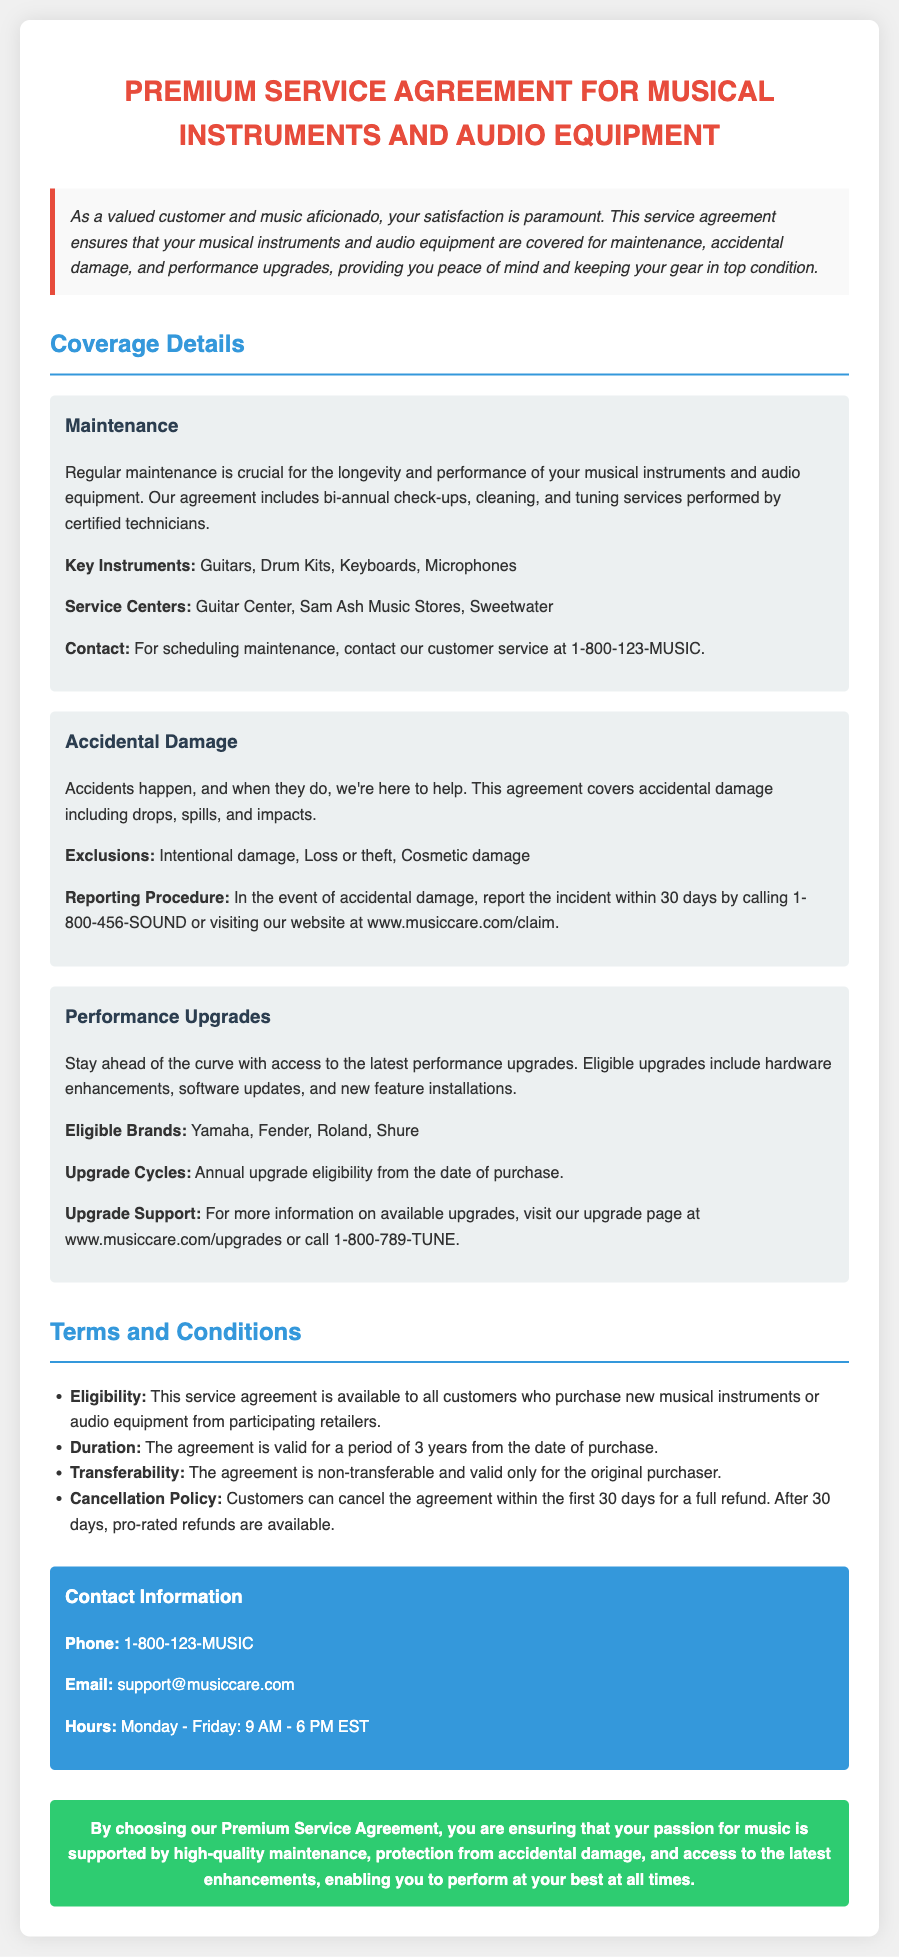What is the duration of the service agreement? The document states that the agreement is valid for a period of 3 years from the date of purchase.
Answer: 3 years What types of damage are excluded from coverage? The exclusions listed include intentional damage, loss or theft, and cosmetic damage.
Answer: Intentional damage, Loss or theft, Cosmetic damage What is the contact number for maintenance scheduling? The document provides the customer service contact number specifically for scheduling maintenance as 1-800-123-MUSIC.
Answer: 1-800-123-MUSIC What brands are eligible for performance upgrades? The document lists eligible brands for performance upgrades as Yamaha, Fender, Roland, and Shure.
Answer: Yamaha, Fender, Roland, Shure How often can performance upgrades be accessed? The document mentions that eligible customers can access upgrades annually from the date of purchase.
Answer: Annual What is the cancellation policy within the first 30 days? It states that customers can cancel the agreement within the first 30 days for a full refund.
Answer: Full refund What key instruments are included in the maintenance coverage? The key instruments covered under maintenance include guitars, drum kits, keyboards, and microphones.
Answer: Guitars, Drum Kits, Keyboards, Microphones Where can customers report accidental damage? According to the document, accidental damage can be reported by calling 1-800-456-SOUND or visiting the website www.musiccare.com/claim.
Answer: 1-800-456-SOUND or www.musiccare.com/claim What type of service does the maintenance coverage include? The maintenance coverage includes bi-annual check-ups, cleaning, and tuning services performed by certified technicians.
Answer: Bi-annual check-ups, cleaning, and tuning services 